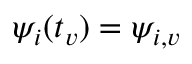Convert formula to latex. <formula><loc_0><loc_0><loc_500><loc_500>\psi _ { i } ( t _ { v } ) = \psi _ { i , v }</formula> 